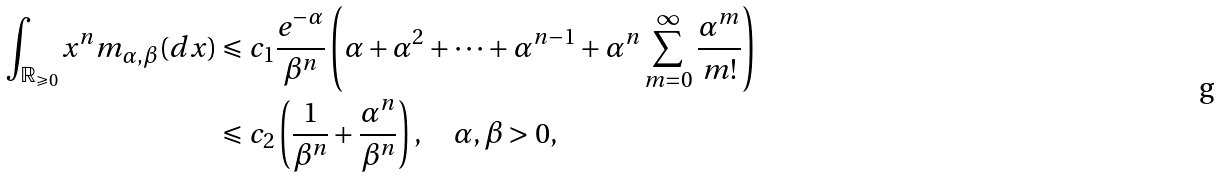<formula> <loc_0><loc_0><loc_500><loc_500>\int _ { \mathbb { R } _ { \geqslant 0 } } x ^ { n } m _ { \alpha , \beta } ( d x ) & \leqslant c _ { 1 } \frac { e ^ { - \alpha } } { \beta ^ { n } } \left ( \alpha + \alpha ^ { 2 } + \cdots + \alpha ^ { n - 1 } + \alpha ^ { n } \sum _ { m = 0 } ^ { \infty } \frac { \alpha ^ { m } } { m ! } \right ) \\ & \leqslant c _ { 2 } \left ( \frac { 1 } { \beta ^ { n } } + \frac { \alpha ^ { n } } { \beta ^ { n } } \right ) , \quad \alpha , \beta > 0 ,</formula> 